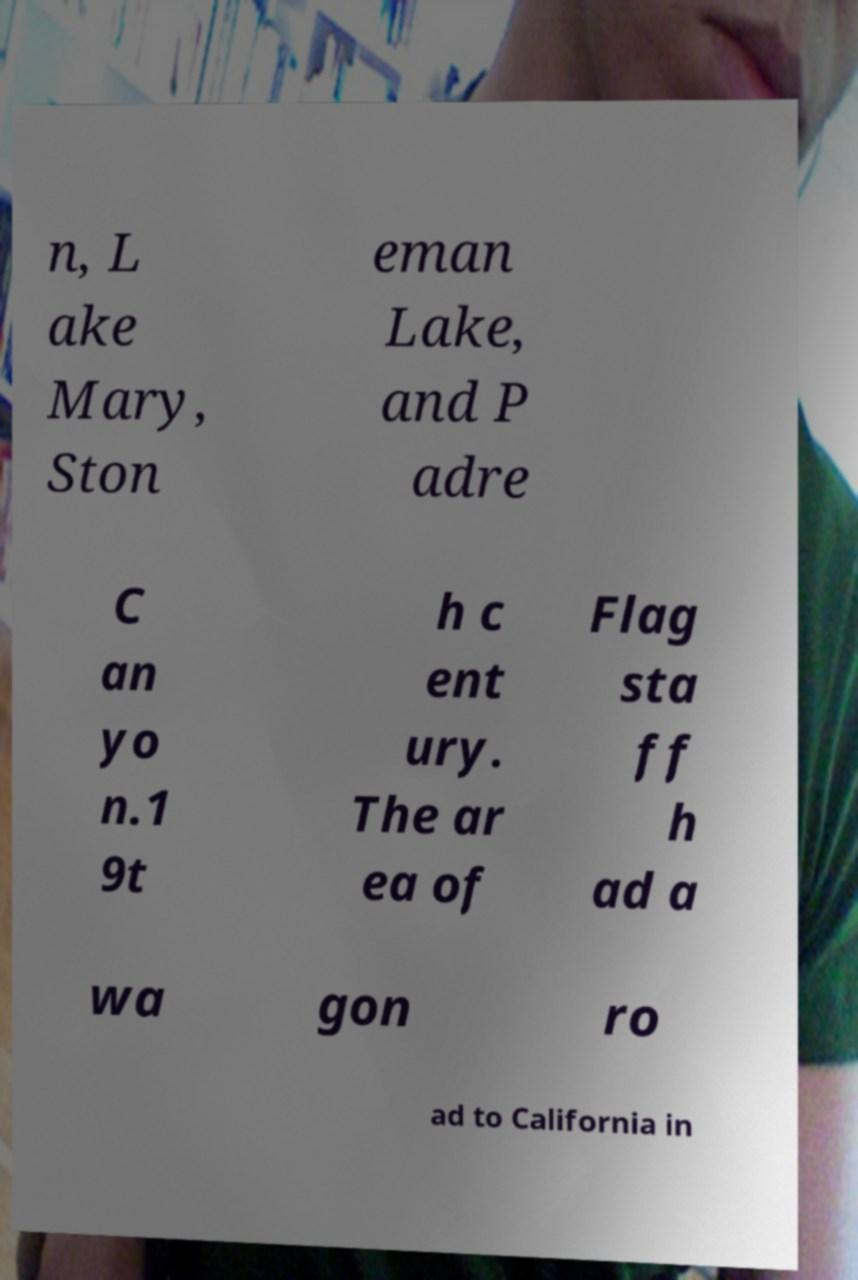Could you assist in decoding the text presented in this image and type it out clearly? n, L ake Mary, Ston eman Lake, and P adre C an yo n.1 9t h c ent ury. The ar ea of Flag sta ff h ad a wa gon ro ad to California in 